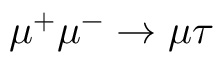<formula> <loc_0><loc_0><loc_500><loc_500>\mu ^ { + } \mu ^ { - } \to \mu \tau</formula> 